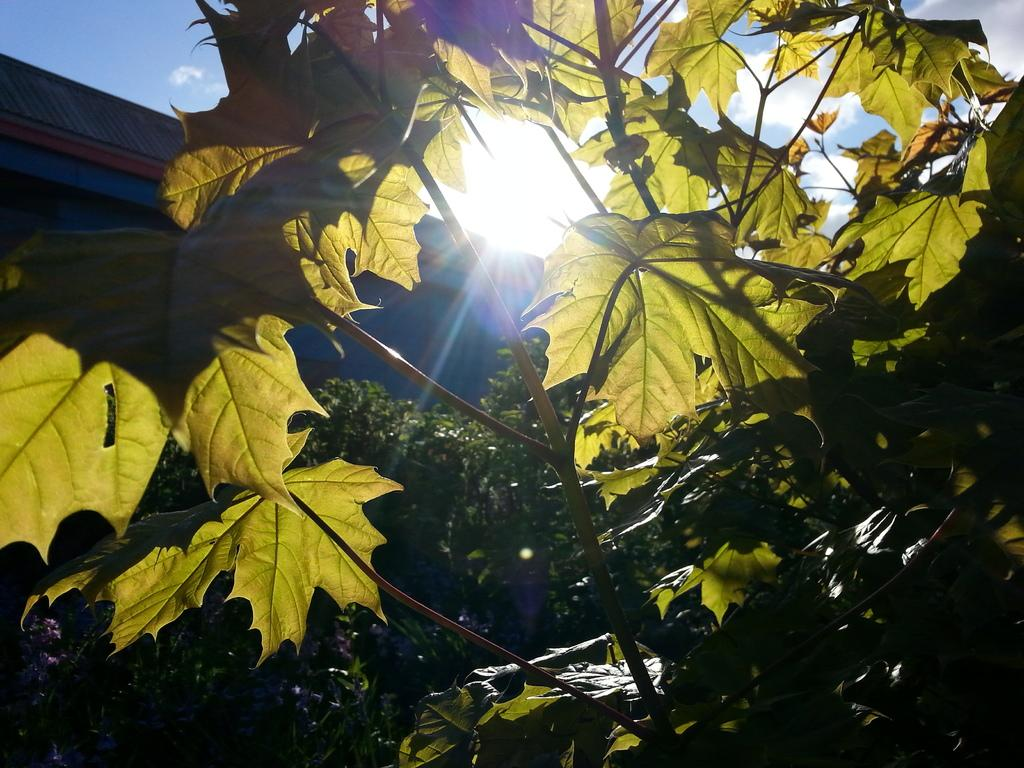What type of natural elements can be seen in the image? There are leaves and plants in the image. What type of structure is visible in the image? There is a roof visible in the image. What can be seen in the sky in the image? Clouds are present in the sky in the image. What type of iron is being controlled by the person in the image? There is no person or iron present in the image. 